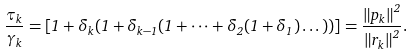<formula> <loc_0><loc_0><loc_500><loc_500>\frac { \tau _ { k } } { \gamma _ { k } } = \left [ 1 + \delta _ { k } ( 1 + \delta _ { k - 1 } ( 1 + \dots + \delta _ { 2 } ( 1 + \delta _ { 1 } ) \dots ) ) \right ] = \frac { \left \| p _ { k } \right \| ^ { 2 } } { \left \| r _ { k } \right \| ^ { 2 } } .</formula> 